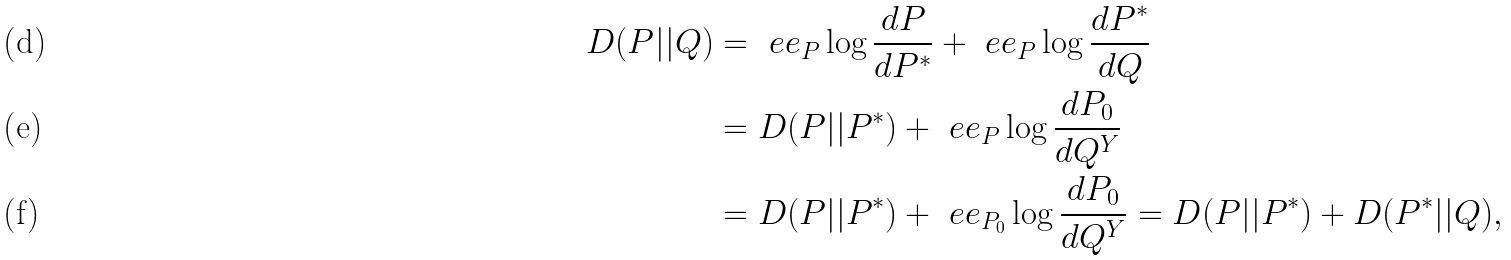Convert formula to latex. <formula><loc_0><loc_0><loc_500><loc_500>D ( P | | Q ) & = \ e e _ { P } \log \frac { d P } { d P ^ { * } } + \ e e _ { P } \log \frac { d P ^ { * } } { d Q } \\ & = D ( P | | P ^ { * } ) + \ e e _ { P } \log \frac { d P _ { 0 } } { d Q ^ { Y } } \\ & = D ( P | | P ^ { * } ) + \ e e _ { P _ { 0 } } \log \frac { d P _ { 0 } } { d Q ^ { Y } } = D ( P | | P ^ { * } ) + D ( P ^ { * } | | Q ) ,</formula> 